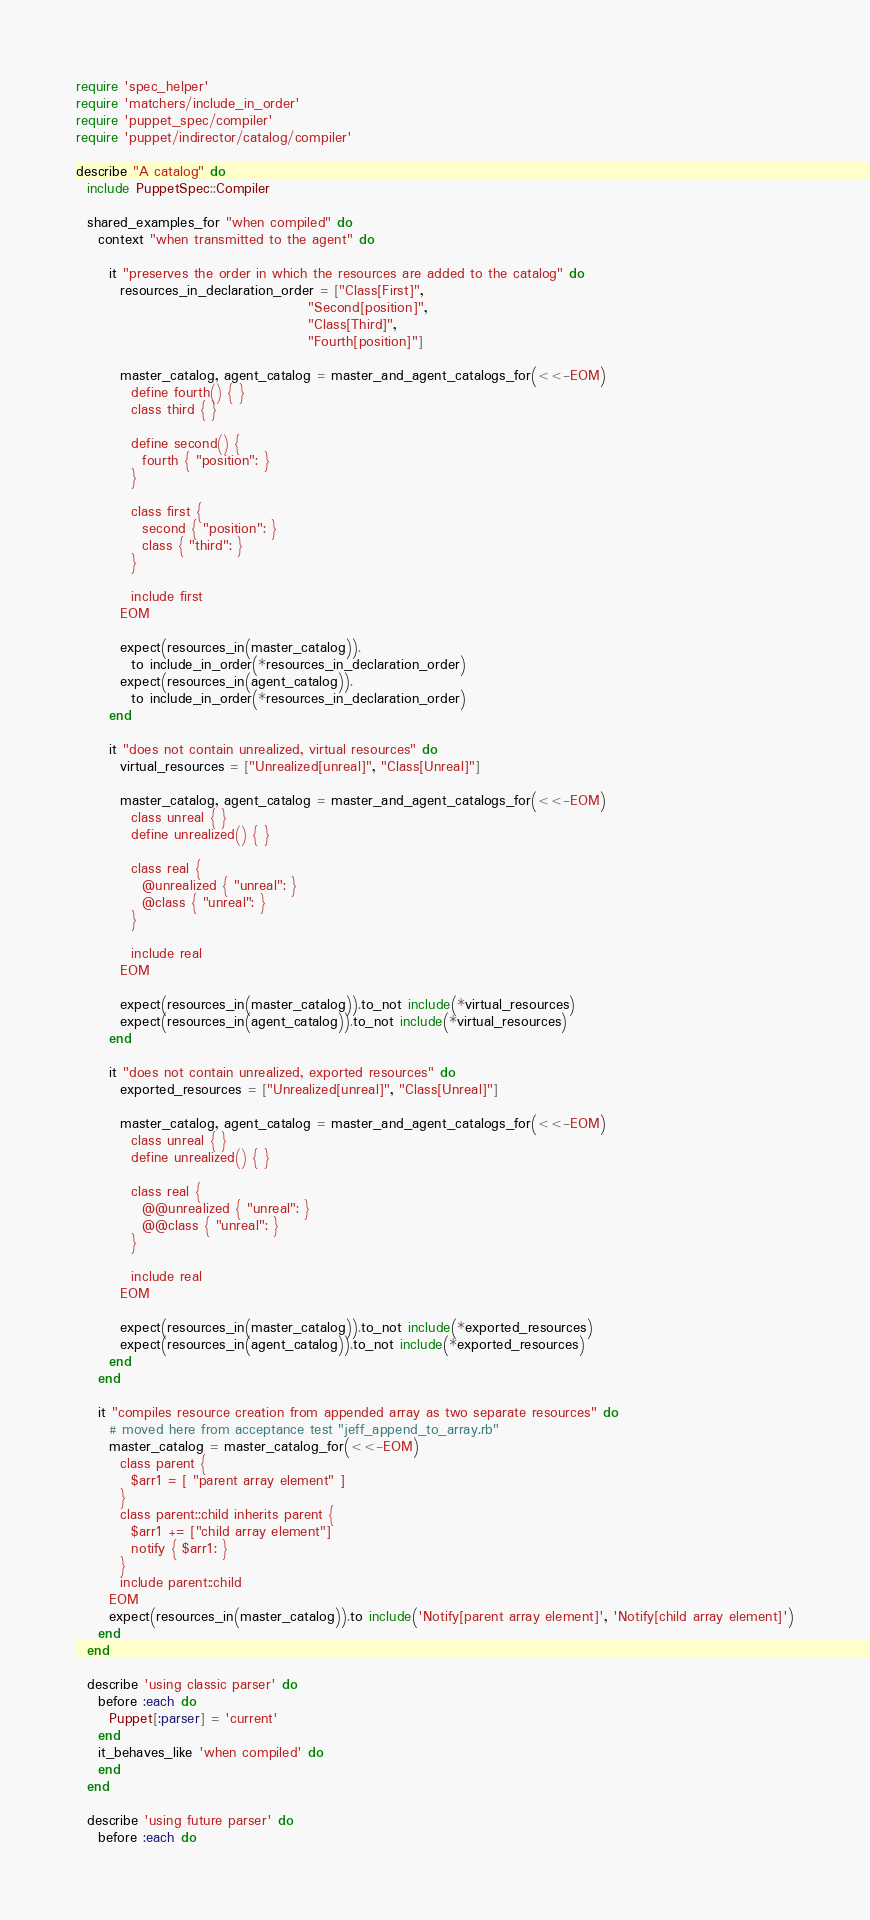Convert code to text. <code><loc_0><loc_0><loc_500><loc_500><_Ruby_>require 'spec_helper'
require 'matchers/include_in_order'
require 'puppet_spec/compiler'
require 'puppet/indirector/catalog/compiler'

describe "A catalog" do
  include PuppetSpec::Compiler

  shared_examples_for "when compiled" do
    context "when transmitted to the agent" do

      it "preserves the order in which the resources are added to the catalog" do
        resources_in_declaration_order = ["Class[First]",
                                          "Second[position]",
                                          "Class[Third]",
                                          "Fourth[position]"]

        master_catalog, agent_catalog = master_and_agent_catalogs_for(<<-EOM)
          define fourth() { }
          class third { }

          define second() {
            fourth { "position": }
          }

          class first {
            second { "position": }
            class { "third": }
          }

          include first
        EOM

        expect(resources_in(master_catalog)).
          to include_in_order(*resources_in_declaration_order)
        expect(resources_in(agent_catalog)).
          to include_in_order(*resources_in_declaration_order)
      end

      it "does not contain unrealized, virtual resources" do
        virtual_resources = ["Unrealized[unreal]", "Class[Unreal]"]

        master_catalog, agent_catalog = master_and_agent_catalogs_for(<<-EOM)
          class unreal { }
          define unrealized() { }

          class real {
            @unrealized { "unreal": }
            @class { "unreal": }
          }

          include real
        EOM

        expect(resources_in(master_catalog)).to_not include(*virtual_resources)
        expect(resources_in(agent_catalog)).to_not include(*virtual_resources)
      end

      it "does not contain unrealized, exported resources" do
        exported_resources = ["Unrealized[unreal]", "Class[Unreal]"]

        master_catalog, agent_catalog = master_and_agent_catalogs_for(<<-EOM)
          class unreal { }
          define unrealized() { }

          class real {
            @@unrealized { "unreal": }
            @@class { "unreal": }
          }

          include real
        EOM

        expect(resources_in(master_catalog)).to_not include(*exported_resources)
        expect(resources_in(agent_catalog)).to_not include(*exported_resources)
      end
    end

    it "compiles resource creation from appended array as two separate resources" do
      # moved here from acceptance test "jeff_append_to_array.rb"
      master_catalog = master_catalog_for(<<-EOM)
        class parent {
          $arr1 = [ "parent array element" ]
        }
        class parent::child inherits parent {
          $arr1 += ["child array element"]
          notify { $arr1: }
        }
        include parent::child
      EOM
      expect(resources_in(master_catalog)).to include('Notify[parent array element]', 'Notify[child array element]')
    end
  end

  describe 'using classic parser' do
    before :each do
      Puppet[:parser] = 'current'
    end
    it_behaves_like 'when compiled' do
    end
  end

  describe 'using future parser' do
    before :each do</code> 